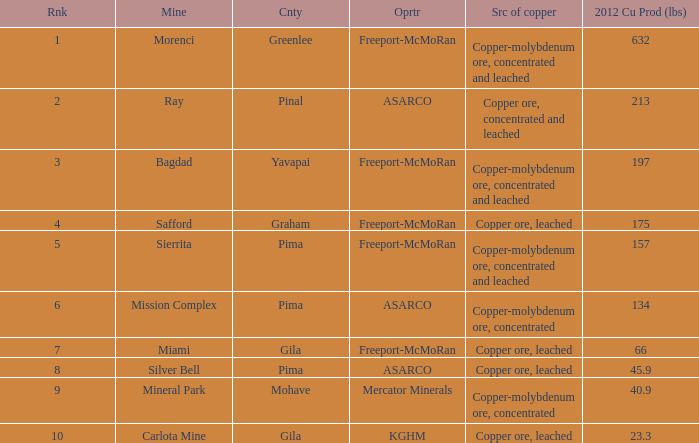Could you parse the entire table as a dict? {'header': ['Rnk', 'Mine', 'Cnty', 'Oprtr', 'Src of copper', '2012 Cu Prod (lbs)'], 'rows': [['1', 'Morenci', 'Greenlee', 'Freeport-McMoRan', 'Copper-molybdenum ore, concentrated and leached', '632'], ['2', 'Ray', 'Pinal', 'ASARCO', 'Copper ore, concentrated and leached', '213'], ['3', 'Bagdad', 'Yavapai', 'Freeport-McMoRan', 'Copper-molybdenum ore, concentrated and leached', '197'], ['4', 'Safford', 'Graham', 'Freeport-McMoRan', 'Copper ore, leached', '175'], ['5', 'Sierrita', 'Pima', 'Freeport-McMoRan', 'Copper-molybdenum ore, concentrated and leached', '157'], ['6', 'Mission Complex', 'Pima', 'ASARCO', 'Copper-molybdenum ore, concentrated', '134'], ['7', 'Miami', 'Gila', 'Freeport-McMoRan', 'Copper ore, leached', '66'], ['8', 'Silver Bell', 'Pima', 'ASARCO', 'Copper ore, leached', '45.9'], ['9', 'Mineral Park', 'Mohave', 'Mercator Minerals', 'Copper-molybdenum ore, concentrated', '40.9'], ['10', 'Carlota Mine', 'Gila', 'KGHM', 'Copper ore, leached', '23.3']]} Which operator has a rank of 7? Freeport-McMoRan. 